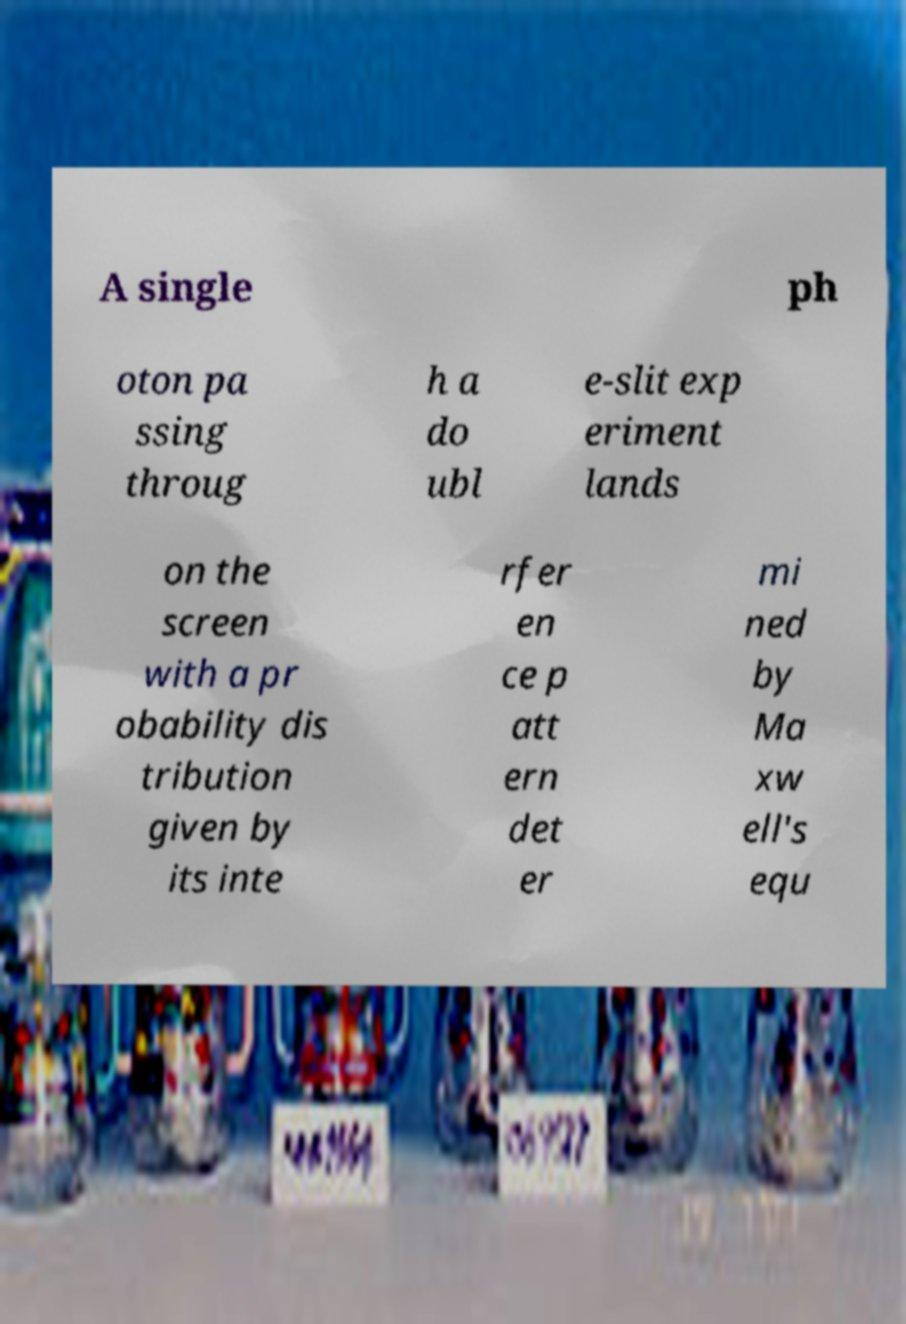I need the written content from this picture converted into text. Can you do that? A single ph oton pa ssing throug h a do ubl e-slit exp eriment lands on the screen with a pr obability dis tribution given by its inte rfer en ce p att ern det er mi ned by Ma xw ell's equ 